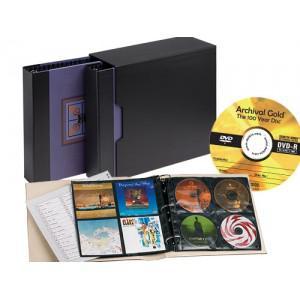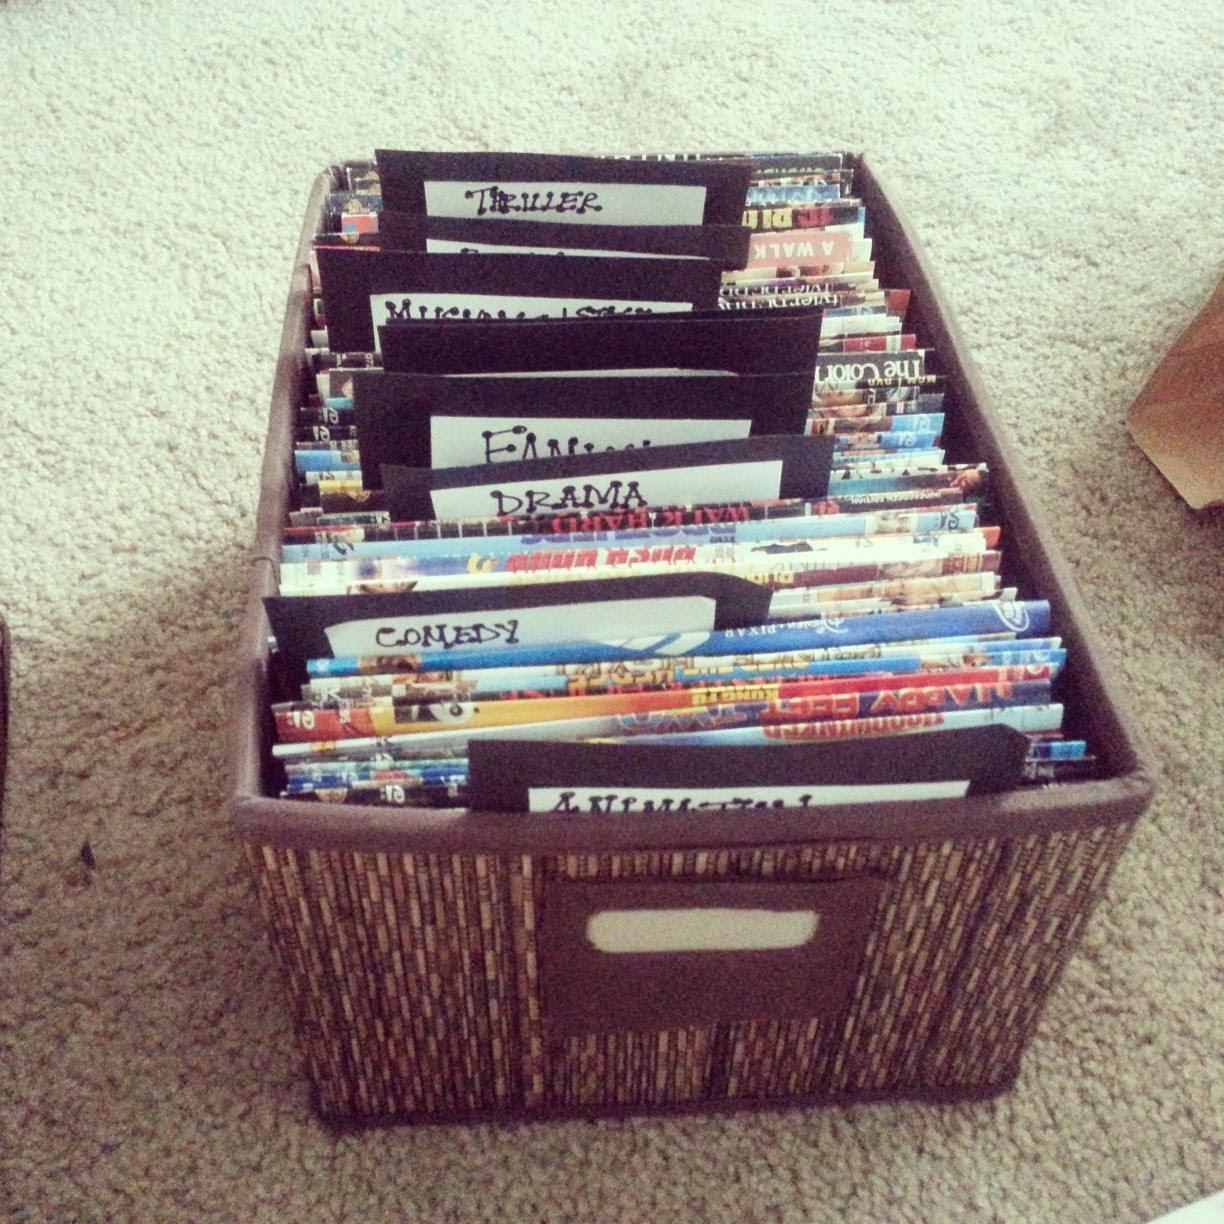The first image is the image on the left, the second image is the image on the right. Evaluate the accuracy of this statement regarding the images: "A bookshelf with 5 shelves is standing by a wall.". Is it true? Answer yes or no. No. The first image is the image on the left, the second image is the image on the right. Examine the images to the left and right. Is the description "In one image, a wooden book shelf with six shelves is standing against a wall." accurate? Answer yes or no. No. 